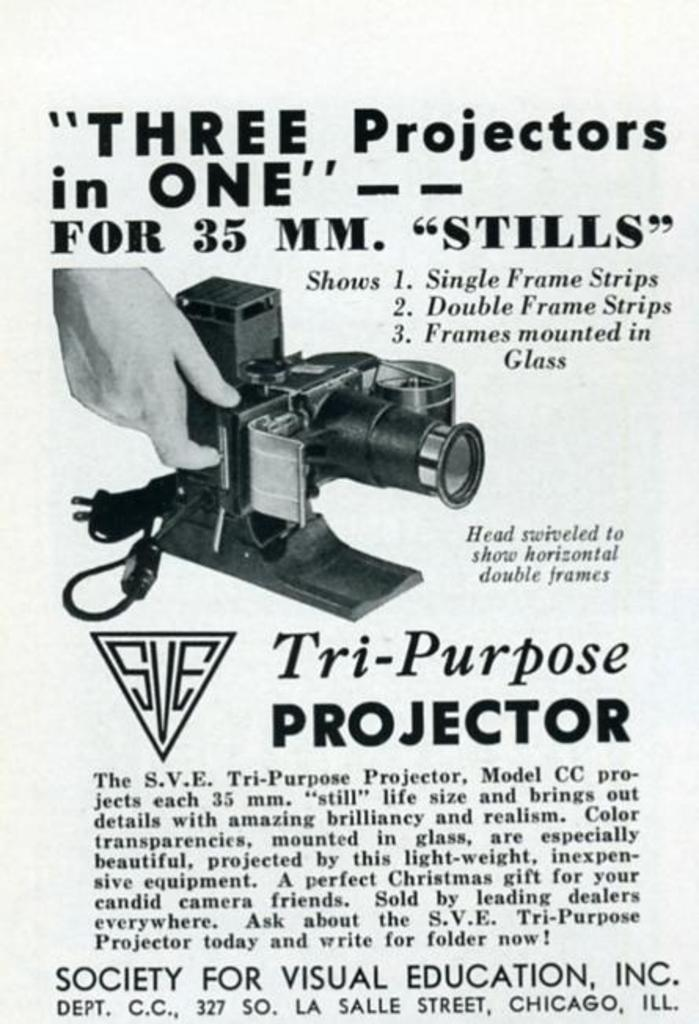<image>
Give a short and clear explanation of the subsequent image. An article that is advertising three projectors in one. 